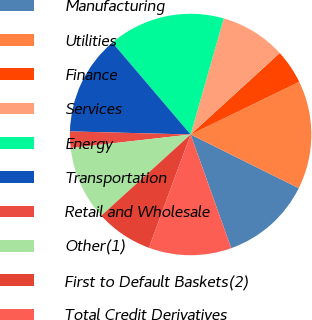Convert chart to OTSL. <chart><loc_0><loc_0><loc_500><loc_500><pie_chart><fcel>Manufacturing<fcel>Utilities<fcel>Finance<fcel>Services<fcel>Energy<fcel>Transportation<fcel>Retail and Wholesale<fcel>Other(1)<fcel>First to Default Baskets(2)<fcel>Total Credit Derivatives<nl><fcel>12.21%<fcel>14.52%<fcel>4.6%<fcel>8.79%<fcel>15.65%<fcel>13.36%<fcel>2.2%<fcel>9.95%<fcel>7.64%<fcel>11.08%<nl></chart> 